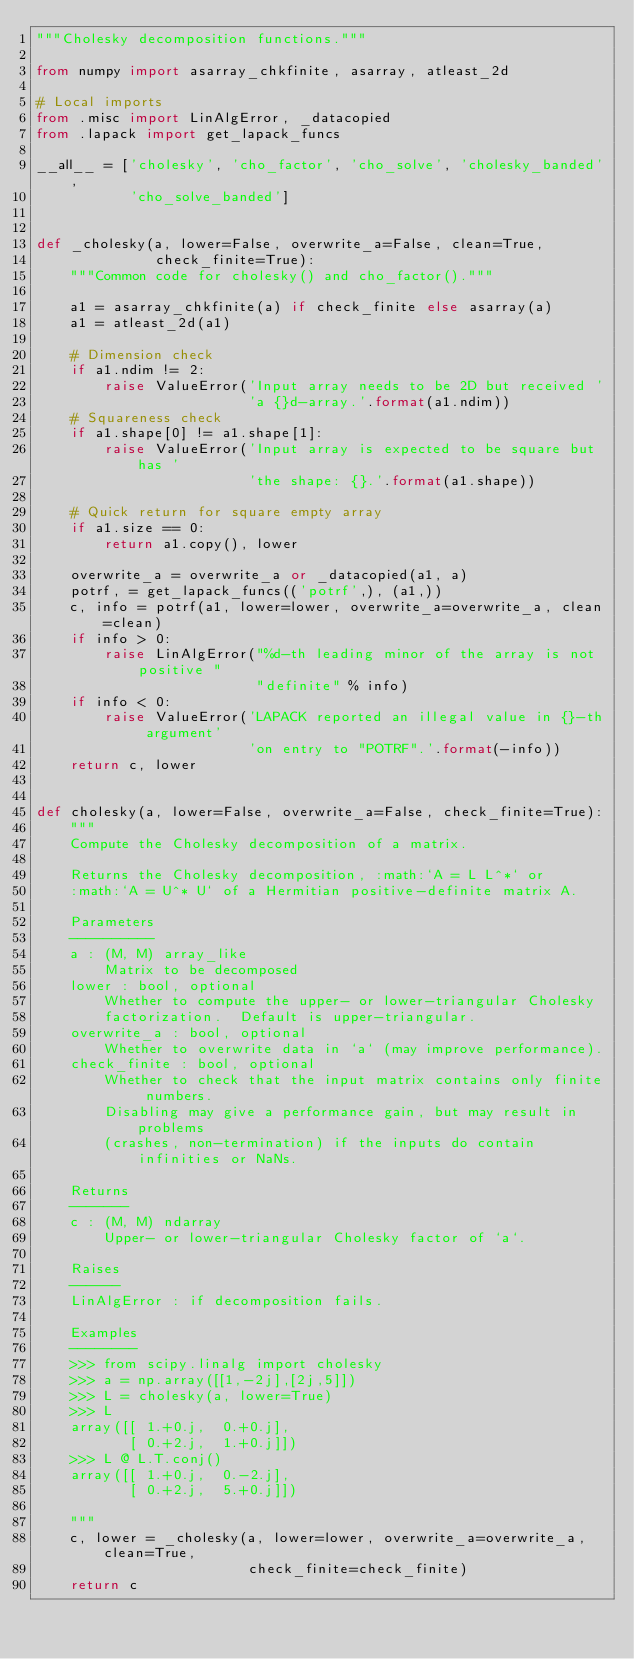Convert code to text. <code><loc_0><loc_0><loc_500><loc_500><_Python_>"""Cholesky decomposition functions."""

from numpy import asarray_chkfinite, asarray, atleast_2d

# Local imports
from .misc import LinAlgError, _datacopied
from .lapack import get_lapack_funcs

__all__ = ['cholesky', 'cho_factor', 'cho_solve', 'cholesky_banded',
           'cho_solve_banded']


def _cholesky(a, lower=False, overwrite_a=False, clean=True,
              check_finite=True):
    """Common code for cholesky() and cho_factor()."""

    a1 = asarray_chkfinite(a) if check_finite else asarray(a)
    a1 = atleast_2d(a1)

    # Dimension check
    if a1.ndim != 2:
        raise ValueError('Input array needs to be 2D but received '
                         'a {}d-array.'.format(a1.ndim))
    # Squareness check
    if a1.shape[0] != a1.shape[1]:
        raise ValueError('Input array is expected to be square but has '
                         'the shape: {}.'.format(a1.shape))

    # Quick return for square empty array
    if a1.size == 0:
        return a1.copy(), lower

    overwrite_a = overwrite_a or _datacopied(a1, a)
    potrf, = get_lapack_funcs(('potrf',), (a1,))
    c, info = potrf(a1, lower=lower, overwrite_a=overwrite_a, clean=clean)
    if info > 0:
        raise LinAlgError("%d-th leading minor of the array is not positive "
                          "definite" % info)
    if info < 0:
        raise ValueError('LAPACK reported an illegal value in {}-th argument'
                         'on entry to "POTRF".'.format(-info))
    return c, lower


def cholesky(a, lower=False, overwrite_a=False, check_finite=True):
    """
    Compute the Cholesky decomposition of a matrix.

    Returns the Cholesky decomposition, :math:`A = L L^*` or
    :math:`A = U^* U` of a Hermitian positive-definite matrix A.

    Parameters
    ----------
    a : (M, M) array_like
        Matrix to be decomposed
    lower : bool, optional
        Whether to compute the upper- or lower-triangular Cholesky
        factorization.  Default is upper-triangular.
    overwrite_a : bool, optional
        Whether to overwrite data in `a` (may improve performance).
    check_finite : bool, optional
        Whether to check that the input matrix contains only finite numbers.
        Disabling may give a performance gain, but may result in problems
        (crashes, non-termination) if the inputs do contain infinities or NaNs.

    Returns
    -------
    c : (M, M) ndarray
        Upper- or lower-triangular Cholesky factor of `a`.

    Raises
    ------
    LinAlgError : if decomposition fails.

    Examples
    --------
    >>> from scipy.linalg import cholesky
    >>> a = np.array([[1,-2j],[2j,5]])
    >>> L = cholesky(a, lower=True)
    >>> L
    array([[ 1.+0.j,  0.+0.j],
           [ 0.+2.j,  1.+0.j]])
    >>> L @ L.T.conj()
    array([[ 1.+0.j,  0.-2.j],
           [ 0.+2.j,  5.+0.j]])

    """
    c, lower = _cholesky(a, lower=lower, overwrite_a=overwrite_a, clean=True,
                         check_finite=check_finite)
    return c

</code> 